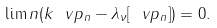Convert formula to latex. <formula><loc_0><loc_0><loc_500><loc_500>\lim n ( k \| \ v p _ { n } \| - \lambda _ { \nu } [ \ v p _ { n } ] ) = 0 .</formula> 